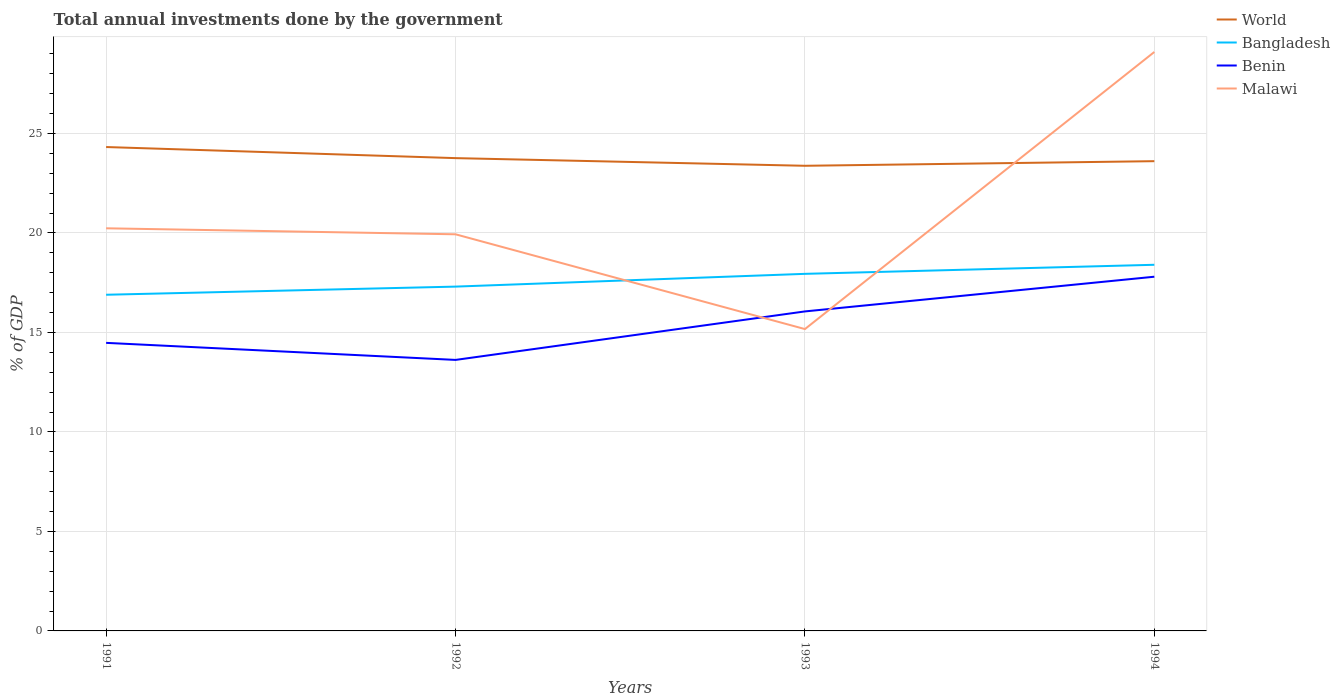Does the line corresponding to Benin intersect with the line corresponding to Bangladesh?
Your answer should be very brief. No. Is the number of lines equal to the number of legend labels?
Your answer should be compact. Yes. Across all years, what is the maximum total annual investments done by the government in Bangladesh?
Your answer should be compact. 16.9. In which year was the total annual investments done by the government in World maximum?
Give a very brief answer. 1993. What is the total total annual investments done by the government in Malawi in the graph?
Your answer should be very brief. -8.86. What is the difference between the highest and the second highest total annual investments done by the government in World?
Your answer should be compact. 0.94. What is the difference between the highest and the lowest total annual investments done by the government in Bangladesh?
Your answer should be very brief. 2. Is the total annual investments done by the government in Malawi strictly greater than the total annual investments done by the government in World over the years?
Offer a very short reply. No. How many years are there in the graph?
Your answer should be compact. 4. What is the difference between two consecutive major ticks on the Y-axis?
Your answer should be very brief. 5. Are the values on the major ticks of Y-axis written in scientific E-notation?
Make the answer very short. No. Does the graph contain any zero values?
Offer a very short reply. No. How many legend labels are there?
Ensure brevity in your answer.  4. What is the title of the graph?
Provide a succinct answer. Total annual investments done by the government. What is the label or title of the X-axis?
Ensure brevity in your answer.  Years. What is the label or title of the Y-axis?
Ensure brevity in your answer.  % of GDP. What is the % of GDP of World in 1991?
Your answer should be very brief. 24.32. What is the % of GDP in Bangladesh in 1991?
Keep it short and to the point. 16.9. What is the % of GDP of Benin in 1991?
Offer a terse response. 14.48. What is the % of GDP of Malawi in 1991?
Offer a terse response. 20.24. What is the % of GDP of World in 1992?
Give a very brief answer. 23.76. What is the % of GDP of Bangladesh in 1992?
Keep it short and to the point. 17.31. What is the % of GDP of Benin in 1992?
Your answer should be very brief. 13.62. What is the % of GDP in Malawi in 1992?
Your answer should be very brief. 19.93. What is the % of GDP of World in 1993?
Your answer should be very brief. 23.38. What is the % of GDP in Bangladesh in 1993?
Your answer should be very brief. 17.95. What is the % of GDP in Benin in 1993?
Offer a terse response. 16.06. What is the % of GDP of Malawi in 1993?
Provide a succinct answer. 15.17. What is the % of GDP in World in 1994?
Provide a short and direct response. 23.61. What is the % of GDP of Bangladesh in 1994?
Your answer should be compact. 18.4. What is the % of GDP of Benin in 1994?
Provide a succinct answer. 17.8. What is the % of GDP in Malawi in 1994?
Your response must be concise. 29.1. Across all years, what is the maximum % of GDP of World?
Your answer should be very brief. 24.32. Across all years, what is the maximum % of GDP of Bangladesh?
Give a very brief answer. 18.4. Across all years, what is the maximum % of GDP of Benin?
Provide a succinct answer. 17.8. Across all years, what is the maximum % of GDP of Malawi?
Keep it short and to the point. 29.1. Across all years, what is the minimum % of GDP in World?
Make the answer very short. 23.38. Across all years, what is the minimum % of GDP of Bangladesh?
Offer a very short reply. 16.9. Across all years, what is the minimum % of GDP of Benin?
Make the answer very short. 13.62. Across all years, what is the minimum % of GDP in Malawi?
Keep it short and to the point. 15.17. What is the total % of GDP of World in the graph?
Your response must be concise. 95.07. What is the total % of GDP in Bangladesh in the graph?
Provide a short and direct response. 70.55. What is the total % of GDP in Benin in the graph?
Ensure brevity in your answer.  61.96. What is the total % of GDP of Malawi in the graph?
Provide a short and direct response. 84.44. What is the difference between the % of GDP of World in 1991 and that in 1992?
Make the answer very short. 0.56. What is the difference between the % of GDP of Bangladesh in 1991 and that in 1992?
Offer a terse response. -0.41. What is the difference between the % of GDP in Benin in 1991 and that in 1992?
Offer a very short reply. 0.86. What is the difference between the % of GDP of Malawi in 1991 and that in 1992?
Ensure brevity in your answer.  0.3. What is the difference between the % of GDP of World in 1991 and that in 1993?
Your response must be concise. 0.94. What is the difference between the % of GDP in Bangladesh in 1991 and that in 1993?
Make the answer very short. -1.05. What is the difference between the % of GDP of Benin in 1991 and that in 1993?
Make the answer very short. -1.58. What is the difference between the % of GDP of Malawi in 1991 and that in 1993?
Provide a short and direct response. 5.06. What is the difference between the % of GDP of World in 1991 and that in 1994?
Offer a very short reply. 0.71. What is the difference between the % of GDP in Bangladesh in 1991 and that in 1994?
Your answer should be very brief. -1.51. What is the difference between the % of GDP of Benin in 1991 and that in 1994?
Make the answer very short. -3.32. What is the difference between the % of GDP of Malawi in 1991 and that in 1994?
Provide a succinct answer. -8.86. What is the difference between the % of GDP in World in 1992 and that in 1993?
Offer a terse response. 0.38. What is the difference between the % of GDP in Bangladesh in 1992 and that in 1993?
Offer a very short reply. -0.64. What is the difference between the % of GDP in Benin in 1992 and that in 1993?
Provide a succinct answer. -2.44. What is the difference between the % of GDP of Malawi in 1992 and that in 1993?
Your answer should be very brief. 4.76. What is the difference between the % of GDP of World in 1992 and that in 1994?
Offer a terse response. 0.15. What is the difference between the % of GDP in Bangladesh in 1992 and that in 1994?
Your answer should be very brief. -1.1. What is the difference between the % of GDP of Benin in 1992 and that in 1994?
Your answer should be compact. -4.18. What is the difference between the % of GDP in Malawi in 1992 and that in 1994?
Provide a short and direct response. -9.16. What is the difference between the % of GDP of World in 1993 and that in 1994?
Offer a terse response. -0.23. What is the difference between the % of GDP of Bangladesh in 1993 and that in 1994?
Offer a terse response. -0.46. What is the difference between the % of GDP in Benin in 1993 and that in 1994?
Your response must be concise. -1.74. What is the difference between the % of GDP in Malawi in 1993 and that in 1994?
Offer a very short reply. -13.93. What is the difference between the % of GDP in World in 1991 and the % of GDP in Bangladesh in 1992?
Your answer should be compact. 7.02. What is the difference between the % of GDP of World in 1991 and the % of GDP of Benin in 1992?
Your answer should be compact. 10.7. What is the difference between the % of GDP in World in 1991 and the % of GDP in Malawi in 1992?
Ensure brevity in your answer.  4.39. What is the difference between the % of GDP of Bangladesh in 1991 and the % of GDP of Benin in 1992?
Offer a very short reply. 3.27. What is the difference between the % of GDP of Bangladesh in 1991 and the % of GDP of Malawi in 1992?
Keep it short and to the point. -3.04. What is the difference between the % of GDP in Benin in 1991 and the % of GDP in Malawi in 1992?
Your response must be concise. -5.46. What is the difference between the % of GDP in World in 1991 and the % of GDP in Bangladesh in 1993?
Make the answer very short. 6.37. What is the difference between the % of GDP of World in 1991 and the % of GDP of Benin in 1993?
Make the answer very short. 8.26. What is the difference between the % of GDP in World in 1991 and the % of GDP in Malawi in 1993?
Offer a terse response. 9.15. What is the difference between the % of GDP in Bangladesh in 1991 and the % of GDP in Benin in 1993?
Your answer should be very brief. 0.84. What is the difference between the % of GDP in Bangladesh in 1991 and the % of GDP in Malawi in 1993?
Keep it short and to the point. 1.72. What is the difference between the % of GDP of Benin in 1991 and the % of GDP of Malawi in 1993?
Your answer should be very brief. -0.69. What is the difference between the % of GDP in World in 1991 and the % of GDP in Bangladesh in 1994?
Offer a terse response. 5.92. What is the difference between the % of GDP of World in 1991 and the % of GDP of Benin in 1994?
Offer a terse response. 6.52. What is the difference between the % of GDP of World in 1991 and the % of GDP of Malawi in 1994?
Provide a succinct answer. -4.78. What is the difference between the % of GDP of Bangladesh in 1991 and the % of GDP of Benin in 1994?
Offer a very short reply. -0.91. What is the difference between the % of GDP in Bangladesh in 1991 and the % of GDP in Malawi in 1994?
Keep it short and to the point. -12.2. What is the difference between the % of GDP of Benin in 1991 and the % of GDP of Malawi in 1994?
Provide a short and direct response. -14.62. What is the difference between the % of GDP in World in 1992 and the % of GDP in Bangladesh in 1993?
Provide a short and direct response. 5.82. What is the difference between the % of GDP of World in 1992 and the % of GDP of Benin in 1993?
Give a very brief answer. 7.7. What is the difference between the % of GDP of World in 1992 and the % of GDP of Malawi in 1993?
Give a very brief answer. 8.59. What is the difference between the % of GDP of Bangladesh in 1992 and the % of GDP of Benin in 1993?
Offer a terse response. 1.25. What is the difference between the % of GDP of Bangladesh in 1992 and the % of GDP of Malawi in 1993?
Your response must be concise. 2.13. What is the difference between the % of GDP in Benin in 1992 and the % of GDP in Malawi in 1993?
Your response must be concise. -1.55. What is the difference between the % of GDP of World in 1992 and the % of GDP of Bangladesh in 1994?
Give a very brief answer. 5.36. What is the difference between the % of GDP in World in 1992 and the % of GDP in Benin in 1994?
Your answer should be very brief. 5.96. What is the difference between the % of GDP in World in 1992 and the % of GDP in Malawi in 1994?
Provide a succinct answer. -5.34. What is the difference between the % of GDP of Bangladesh in 1992 and the % of GDP of Benin in 1994?
Your answer should be compact. -0.5. What is the difference between the % of GDP of Bangladesh in 1992 and the % of GDP of Malawi in 1994?
Your response must be concise. -11.79. What is the difference between the % of GDP in Benin in 1992 and the % of GDP in Malawi in 1994?
Your response must be concise. -15.48. What is the difference between the % of GDP of World in 1993 and the % of GDP of Bangladesh in 1994?
Give a very brief answer. 4.98. What is the difference between the % of GDP of World in 1993 and the % of GDP of Benin in 1994?
Provide a short and direct response. 5.58. What is the difference between the % of GDP of World in 1993 and the % of GDP of Malawi in 1994?
Give a very brief answer. -5.72. What is the difference between the % of GDP of Bangladesh in 1993 and the % of GDP of Benin in 1994?
Offer a very short reply. 0.14. What is the difference between the % of GDP of Bangladesh in 1993 and the % of GDP of Malawi in 1994?
Ensure brevity in your answer.  -11.15. What is the difference between the % of GDP of Benin in 1993 and the % of GDP of Malawi in 1994?
Your answer should be very brief. -13.04. What is the average % of GDP of World per year?
Your answer should be compact. 23.77. What is the average % of GDP of Bangladesh per year?
Offer a very short reply. 17.64. What is the average % of GDP in Benin per year?
Make the answer very short. 15.49. What is the average % of GDP of Malawi per year?
Your response must be concise. 21.11. In the year 1991, what is the difference between the % of GDP in World and % of GDP in Bangladesh?
Give a very brief answer. 7.42. In the year 1991, what is the difference between the % of GDP in World and % of GDP in Benin?
Make the answer very short. 9.84. In the year 1991, what is the difference between the % of GDP in World and % of GDP in Malawi?
Your answer should be compact. 4.08. In the year 1991, what is the difference between the % of GDP of Bangladesh and % of GDP of Benin?
Offer a very short reply. 2.42. In the year 1991, what is the difference between the % of GDP of Bangladesh and % of GDP of Malawi?
Provide a succinct answer. -3.34. In the year 1991, what is the difference between the % of GDP in Benin and % of GDP in Malawi?
Offer a terse response. -5.76. In the year 1992, what is the difference between the % of GDP of World and % of GDP of Bangladesh?
Your answer should be compact. 6.46. In the year 1992, what is the difference between the % of GDP in World and % of GDP in Benin?
Ensure brevity in your answer.  10.14. In the year 1992, what is the difference between the % of GDP in World and % of GDP in Malawi?
Your answer should be very brief. 3.83. In the year 1992, what is the difference between the % of GDP in Bangladesh and % of GDP in Benin?
Your response must be concise. 3.68. In the year 1992, what is the difference between the % of GDP of Bangladesh and % of GDP of Malawi?
Offer a very short reply. -2.63. In the year 1992, what is the difference between the % of GDP of Benin and % of GDP of Malawi?
Provide a short and direct response. -6.31. In the year 1993, what is the difference between the % of GDP in World and % of GDP in Bangladesh?
Your answer should be compact. 5.43. In the year 1993, what is the difference between the % of GDP in World and % of GDP in Benin?
Provide a short and direct response. 7.32. In the year 1993, what is the difference between the % of GDP of World and % of GDP of Malawi?
Your response must be concise. 8.21. In the year 1993, what is the difference between the % of GDP in Bangladesh and % of GDP in Benin?
Your answer should be very brief. 1.89. In the year 1993, what is the difference between the % of GDP in Bangladesh and % of GDP in Malawi?
Your answer should be very brief. 2.78. In the year 1993, what is the difference between the % of GDP in Benin and % of GDP in Malawi?
Your response must be concise. 0.89. In the year 1994, what is the difference between the % of GDP in World and % of GDP in Bangladesh?
Make the answer very short. 5.21. In the year 1994, what is the difference between the % of GDP of World and % of GDP of Benin?
Offer a very short reply. 5.81. In the year 1994, what is the difference between the % of GDP of World and % of GDP of Malawi?
Keep it short and to the point. -5.49. In the year 1994, what is the difference between the % of GDP in Bangladesh and % of GDP in Benin?
Ensure brevity in your answer.  0.6. In the year 1994, what is the difference between the % of GDP of Bangladesh and % of GDP of Malawi?
Give a very brief answer. -10.7. In the year 1994, what is the difference between the % of GDP in Benin and % of GDP in Malawi?
Provide a short and direct response. -11.3. What is the ratio of the % of GDP in World in 1991 to that in 1992?
Offer a very short reply. 1.02. What is the ratio of the % of GDP of Bangladesh in 1991 to that in 1992?
Your response must be concise. 0.98. What is the ratio of the % of GDP of Benin in 1991 to that in 1992?
Offer a terse response. 1.06. What is the ratio of the % of GDP of Malawi in 1991 to that in 1992?
Give a very brief answer. 1.02. What is the ratio of the % of GDP in World in 1991 to that in 1993?
Offer a very short reply. 1.04. What is the ratio of the % of GDP in Bangladesh in 1991 to that in 1993?
Your answer should be very brief. 0.94. What is the ratio of the % of GDP in Benin in 1991 to that in 1993?
Make the answer very short. 0.9. What is the ratio of the % of GDP of Malawi in 1991 to that in 1993?
Ensure brevity in your answer.  1.33. What is the ratio of the % of GDP in World in 1991 to that in 1994?
Offer a very short reply. 1.03. What is the ratio of the % of GDP of Bangladesh in 1991 to that in 1994?
Offer a terse response. 0.92. What is the ratio of the % of GDP in Benin in 1991 to that in 1994?
Your answer should be compact. 0.81. What is the ratio of the % of GDP of Malawi in 1991 to that in 1994?
Your response must be concise. 0.7. What is the ratio of the % of GDP in World in 1992 to that in 1993?
Provide a succinct answer. 1.02. What is the ratio of the % of GDP of Bangladesh in 1992 to that in 1993?
Offer a terse response. 0.96. What is the ratio of the % of GDP of Benin in 1992 to that in 1993?
Provide a succinct answer. 0.85. What is the ratio of the % of GDP of Malawi in 1992 to that in 1993?
Your answer should be compact. 1.31. What is the ratio of the % of GDP in Bangladesh in 1992 to that in 1994?
Offer a terse response. 0.94. What is the ratio of the % of GDP in Benin in 1992 to that in 1994?
Offer a terse response. 0.77. What is the ratio of the % of GDP in Malawi in 1992 to that in 1994?
Ensure brevity in your answer.  0.69. What is the ratio of the % of GDP of World in 1993 to that in 1994?
Keep it short and to the point. 0.99. What is the ratio of the % of GDP of Bangladesh in 1993 to that in 1994?
Ensure brevity in your answer.  0.98. What is the ratio of the % of GDP in Benin in 1993 to that in 1994?
Offer a terse response. 0.9. What is the ratio of the % of GDP in Malawi in 1993 to that in 1994?
Keep it short and to the point. 0.52. What is the difference between the highest and the second highest % of GDP of World?
Your answer should be compact. 0.56. What is the difference between the highest and the second highest % of GDP in Bangladesh?
Your answer should be very brief. 0.46. What is the difference between the highest and the second highest % of GDP of Benin?
Your response must be concise. 1.74. What is the difference between the highest and the second highest % of GDP in Malawi?
Your answer should be very brief. 8.86. What is the difference between the highest and the lowest % of GDP of World?
Your response must be concise. 0.94. What is the difference between the highest and the lowest % of GDP of Bangladesh?
Your response must be concise. 1.51. What is the difference between the highest and the lowest % of GDP in Benin?
Your answer should be very brief. 4.18. What is the difference between the highest and the lowest % of GDP of Malawi?
Your answer should be very brief. 13.93. 